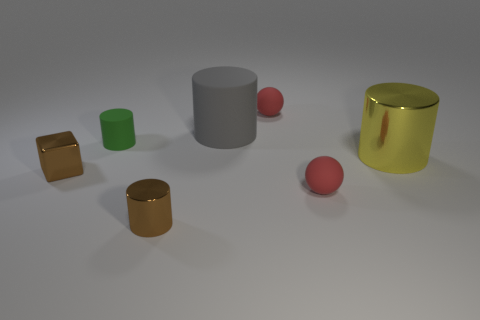What color is the big thing that is to the right of the red thing in front of the tiny green rubber thing?
Offer a terse response. Yellow. Do the tiny rubber cylinder and the large metallic cylinder that is to the right of the brown shiny cylinder have the same color?
Your response must be concise. No. There is a tiny red thing in front of the large object that is on the left side of the big metallic cylinder; how many big gray things are in front of it?
Make the answer very short. 0. There is a tiny brown metal cube; are there any tiny brown cylinders behind it?
Ensure brevity in your answer.  No. Are there any other things that have the same color as the small shiny cube?
Keep it short and to the point. Yes. How many cylinders are either cyan matte things or brown metallic things?
Provide a short and direct response. 1. How many metallic objects are in front of the yellow shiny thing and to the right of the brown cube?
Give a very brief answer. 1. Are there the same number of small things left of the gray rubber thing and small brown shiny cubes behind the brown cube?
Provide a short and direct response. No. There is a tiny brown metallic object that is right of the green object; does it have the same shape as the tiny green object?
Make the answer very short. Yes. What shape is the tiny brown object that is left of the brown cylinder on the left side of the big cylinder that is in front of the tiny green cylinder?
Keep it short and to the point. Cube. 